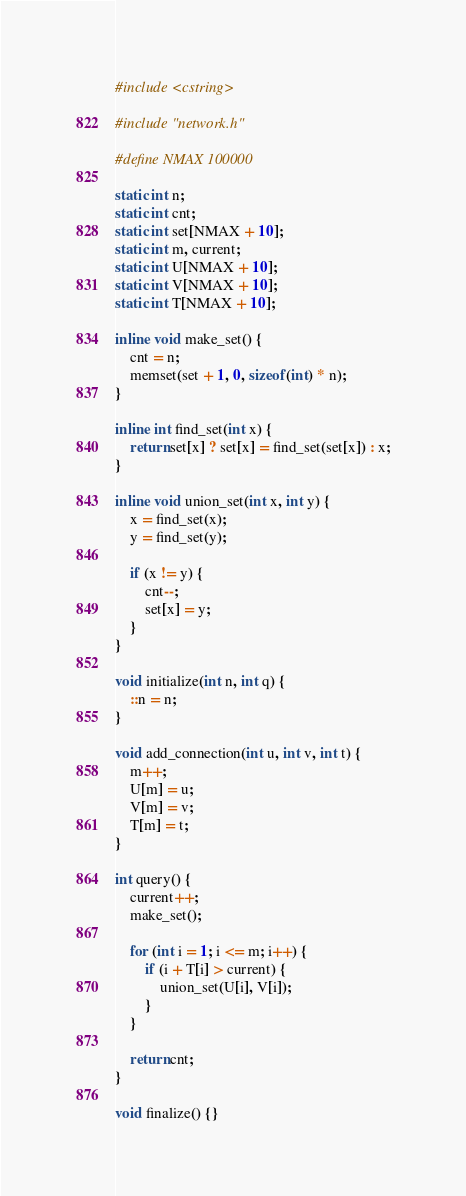Convert code to text. <code><loc_0><loc_0><loc_500><loc_500><_C++_>#include <cstring>

#include "network.h"

#define NMAX 100000

static int n;
static int cnt;
static int set[NMAX + 10];
static int m, current;
static int U[NMAX + 10];
static int V[NMAX + 10];
static int T[NMAX + 10];

inline void make_set() {
    cnt = n;
    memset(set + 1, 0, sizeof(int) * n);
}

inline int find_set(int x) {
    return set[x] ? set[x] = find_set(set[x]) : x;
}

inline void union_set(int x, int y) {
    x = find_set(x);
    y = find_set(y);

    if (x != y) {
        cnt--;
        set[x] = y;
    }
}

void initialize(int n, int q) {
    ::n = n;
}

void add_connection(int u, int v, int t) {
    m++;
    U[m] = u;
    V[m] = v;
    T[m] = t;
}

int query() {
    current++;
    make_set();

    for (int i = 1; i <= m; i++) {
        if (i + T[i] > current) {
            union_set(U[i], V[i]);
        }
    }

    return cnt;
}

void finalize() {}
</code> 